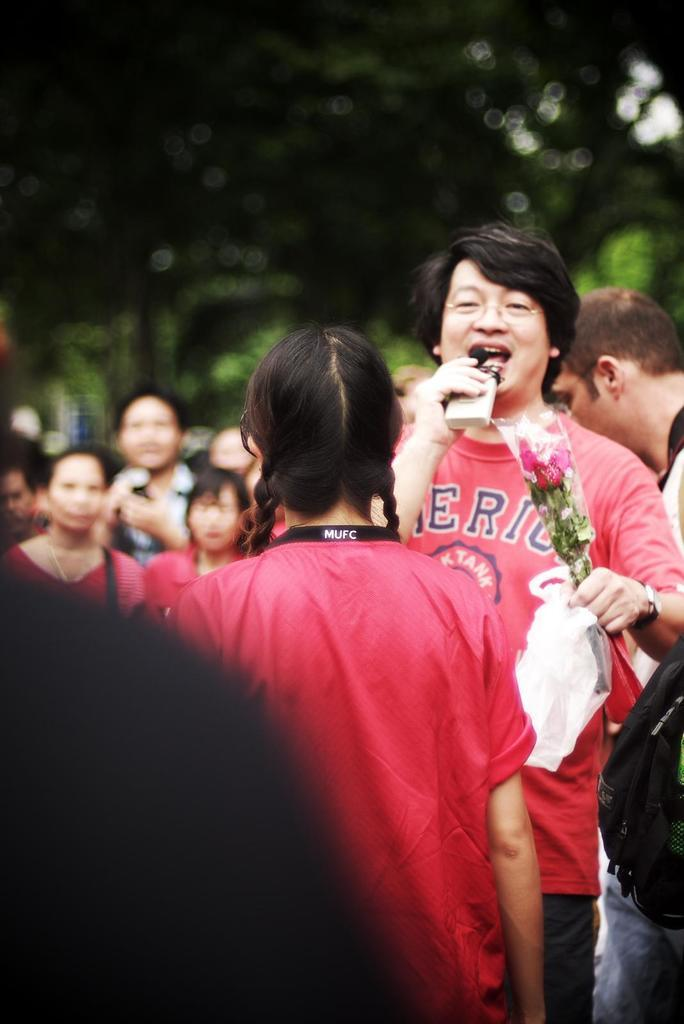What are the people in the image doing? There are people standing in the image. What objects are the people holding in the image? Some of the people are holding flowers, and some are holding a bottle. What type of sound can be heard coming from the flowers in the image? There is no sound coming from the flowers in the image, as flowers do not produce sound. 